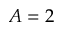<formula> <loc_0><loc_0><loc_500><loc_500>A = 2</formula> 